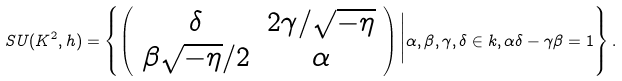<formula> <loc_0><loc_0><loc_500><loc_500>S U ( K ^ { 2 } , h ) = \left \{ \left ( \begin{array} { c c } \delta & 2 \gamma / \sqrt { - \eta } \\ \beta \sqrt { - \eta } / 2 & \alpha \end{array} \right ) \Big | \alpha , \beta , \gamma , \delta \in k , \alpha \delta - \gamma \beta = 1 \right \} .</formula> 